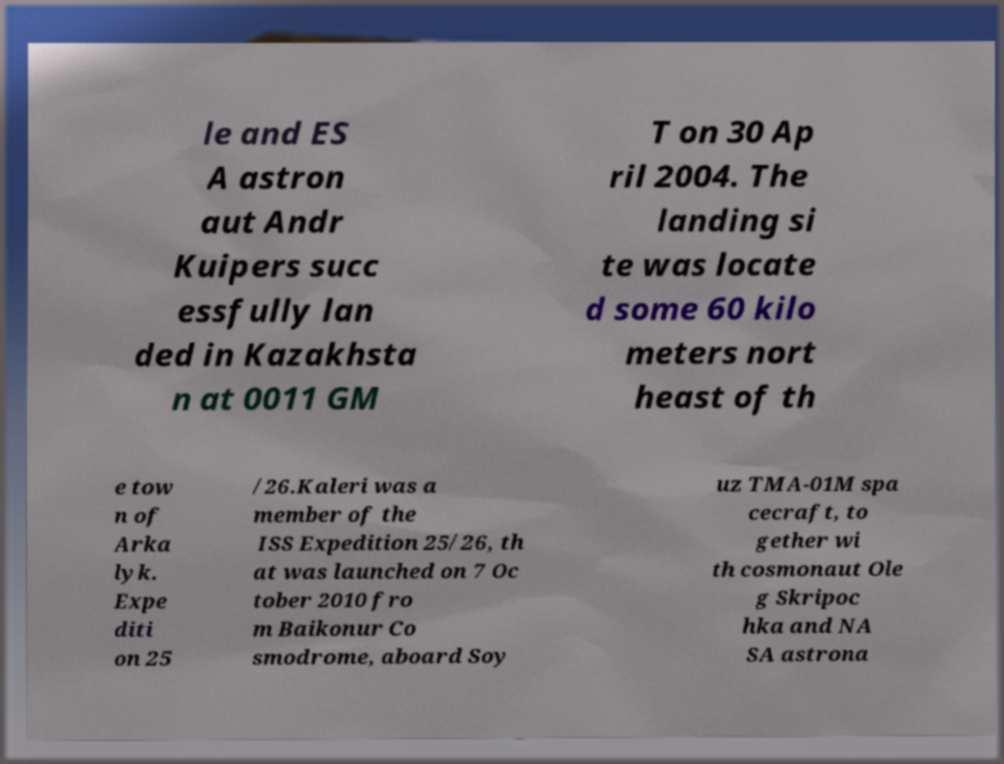Can you read and provide the text displayed in the image?This photo seems to have some interesting text. Can you extract and type it out for me? le and ES A astron aut Andr Kuipers succ essfully lan ded in Kazakhsta n at 0011 GM T on 30 Ap ril 2004. The landing si te was locate d some 60 kilo meters nort heast of th e tow n of Arka lyk. Expe diti on 25 /26.Kaleri was a member of the ISS Expedition 25/26, th at was launched on 7 Oc tober 2010 fro m Baikonur Co smodrome, aboard Soy uz TMA-01M spa cecraft, to gether wi th cosmonaut Ole g Skripoc hka and NA SA astrona 